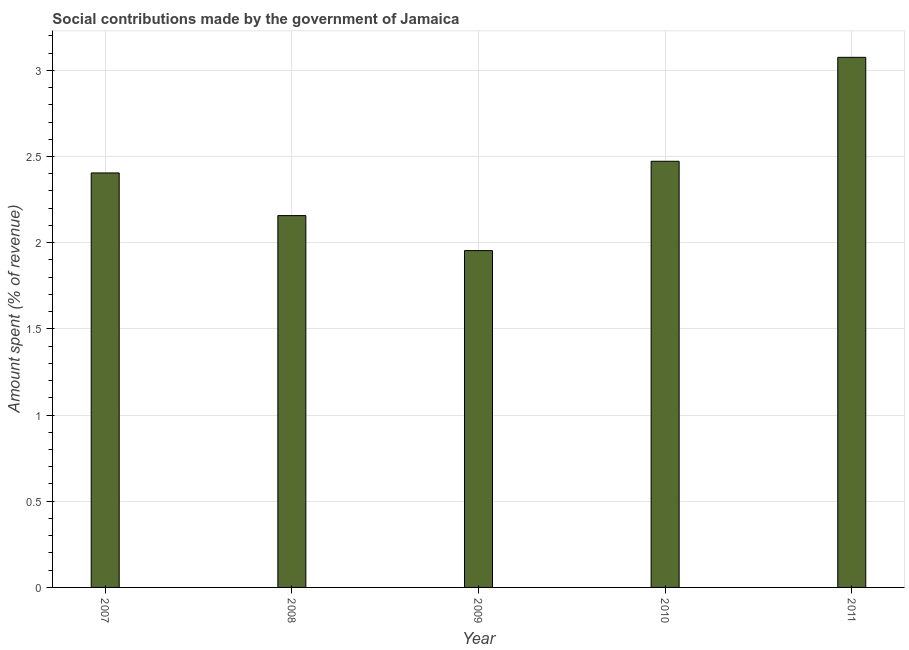What is the title of the graph?
Your answer should be compact. Social contributions made by the government of Jamaica. What is the label or title of the X-axis?
Give a very brief answer. Year. What is the label or title of the Y-axis?
Your answer should be compact. Amount spent (% of revenue). What is the amount spent in making social contributions in 2008?
Provide a succinct answer. 2.16. Across all years, what is the maximum amount spent in making social contributions?
Ensure brevity in your answer.  3.08. Across all years, what is the minimum amount spent in making social contributions?
Provide a short and direct response. 1.95. In which year was the amount spent in making social contributions maximum?
Your response must be concise. 2011. In which year was the amount spent in making social contributions minimum?
Offer a very short reply. 2009. What is the sum of the amount spent in making social contributions?
Ensure brevity in your answer.  12.06. What is the difference between the amount spent in making social contributions in 2008 and 2011?
Ensure brevity in your answer.  -0.92. What is the average amount spent in making social contributions per year?
Your response must be concise. 2.41. What is the median amount spent in making social contributions?
Offer a terse response. 2.4. In how many years, is the amount spent in making social contributions greater than 3 %?
Offer a very short reply. 1. Do a majority of the years between 2010 and 2007 (inclusive) have amount spent in making social contributions greater than 2.6 %?
Offer a very short reply. Yes. What is the ratio of the amount spent in making social contributions in 2008 to that in 2010?
Offer a terse response. 0.87. What is the difference between the highest and the second highest amount spent in making social contributions?
Keep it short and to the point. 0.6. Is the sum of the amount spent in making social contributions in 2008 and 2010 greater than the maximum amount spent in making social contributions across all years?
Ensure brevity in your answer.  Yes. What is the difference between the highest and the lowest amount spent in making social contributions?
Offer a very short reply. 1.12. In how many years, is the amount spent in making social contributions greater than the average amount spent in making social contributions taken over all years?
Your response must be concise. 2. How many bars are there?
Give a very brief answer. 5. Are the values on the major ticks of Y-axis written in scientific E-notation?
Ensure brevity in your answer.  No. What is the Amount spent (% of revenue) in 2007?
Give a very brief answer. 2.4. What is the Amount spent (% of revenue) in 2008?
Offer a very short reply. 2.16. What is the Amount spent (% of revenue) of 2009?
Offer a terse response. 1.95. What is the Amount spent (% of revenue) in 2010?
Offer a very short reply. 2.47. What is the Amount spent (% of revenue) of 2011?
Your response must be concise. 3.08. What is the difference between the Amount spent (% of revenue) in 2007 and 2008?
Give a very brief answer. 0.25. What is the difference between the Amount spent (% of revenue) in 2007 and 2009?
Give a very brief answer. 0.45. What is the difference between the Amount spent (% of revenue) in 2007 and 2010?
Make the answer very short. -0.07. What is the difference between the Amount spent (% of revenue) in 2007 and 2011?
Your answer should be very brief. -0.67. What is the difference between the Amount spent (% of revenue) in 2008 and 2009?
Your answer should be compact. 0.2. What is the difference between the Amount spent (% of revenue) in 2008 and 2010?
Offer a terse response. -0.32. What is the difference between the Amount spent (% of revenue) in 2008 and 2011?
Your answer should be compact. -0.92. What is the difference between the Amount spent (% of revenue) in 2009 and 2010?
Offer a terse response. -0.52. What is the difference between the Amount spent (% of revenue) in 2009 and 2011?
Provide a short and direct response. -1.12. What is the difference between the Amount spent (% of revenue) in 2010 and 2011?
Your answer should be compact. -0.6. What is the ratio of the Amount spent (% of revenue) in 2007 to that in 2008?
Keep it short and to the point. 1.11. What is the ratio of the Amount spent (% of revenue) in 2007 to that in 2009?
Your answer should be compact. 1.23. What is the ratio of the Amount spent (% of revenue) in 2007 to that in 2011?
Offer a terse response. 0.78. What is the ratio of the Amount spent (% of revenue) in 2008 to that in 2009?
Offer a very short reply. 1.1. What is the ratio of the Amount spent (% of revenue) in 2008 to that in 2010?
Your answer should be very brief. 0.87. What is the ratio of the Amount spent (% of revenue) in 2008 to that in 2011?
Offer a terse response. 0.7. What is the ratio of the Amount spent (% of revenue) in 2009 to that in 2010?
Offer a very short reply. 0.79. What is the ratio of the Amount spent (% of revenue) in 2009 to that in 2011?
Make the answer very short. 0.64. What is the ratio of the Amount spent (% of revenue) in 2010 to that in 2011?
Give a very brief answer. 0.8. 